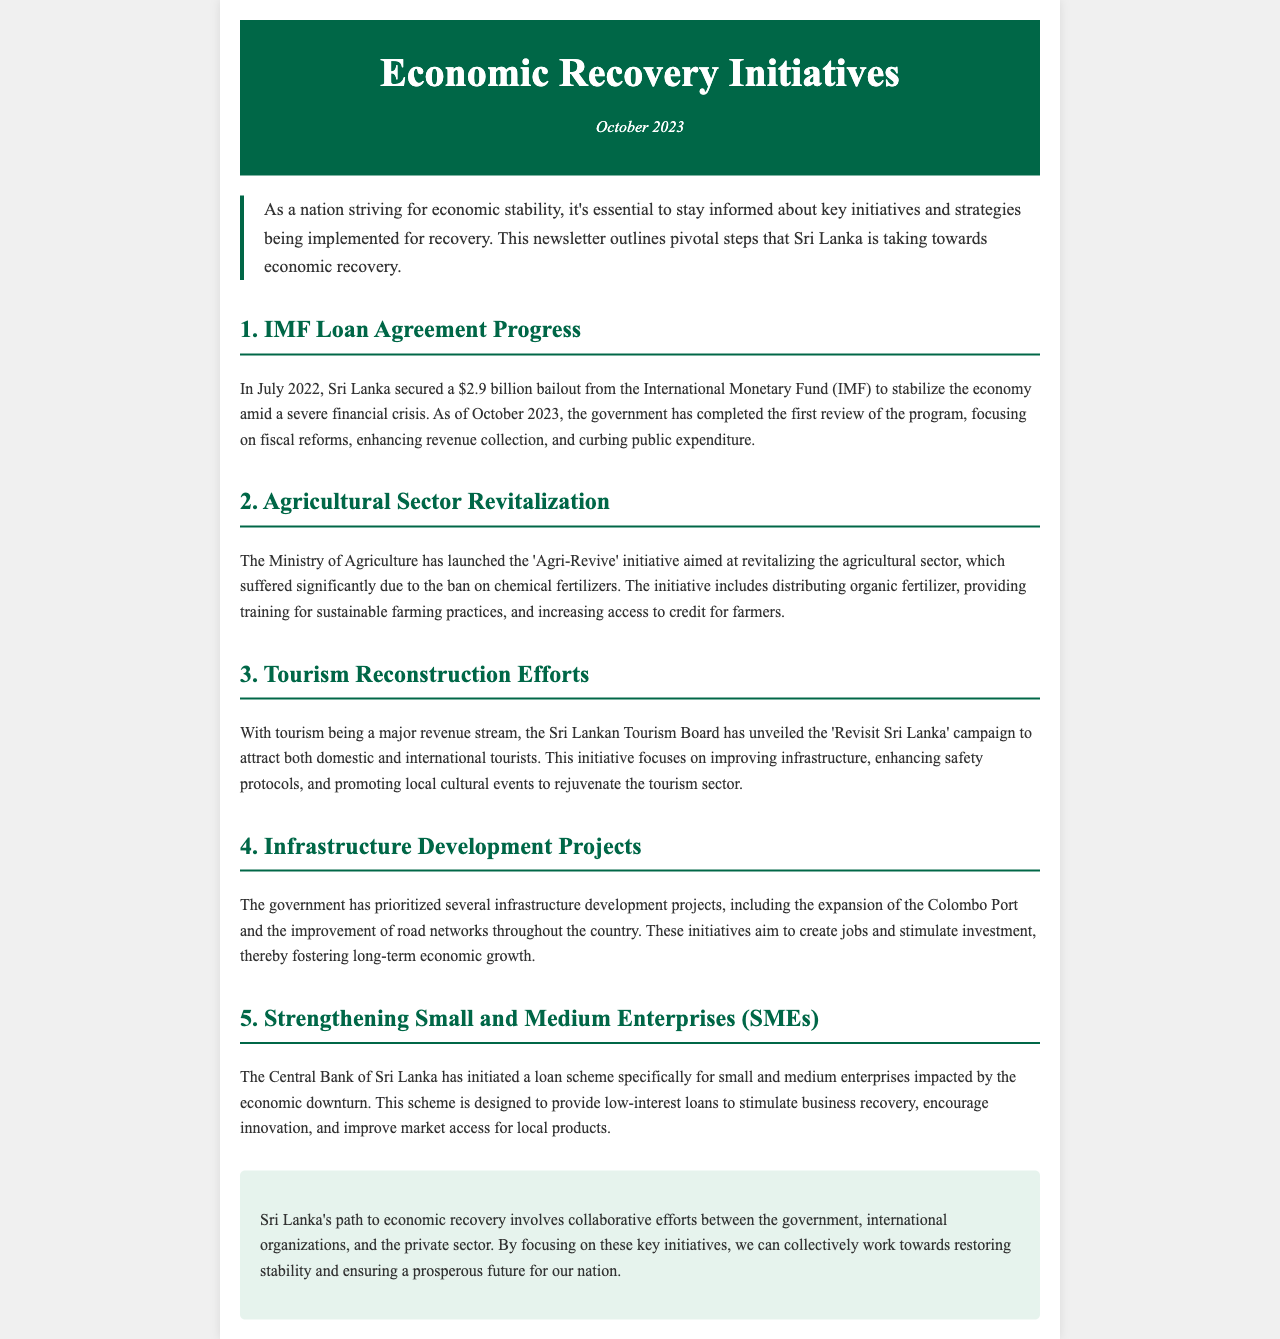What is the total amount of the IMF loan agreement? The IMF loan agreement secured by Sri Lanka is for $2.9 billion.
Answer: $2.9 billion What initiative has the Ministry of Agriculture launched? The initiative launched by the Ministry of Agriculture is called 'Agri-Revive'.
Answer: Agri-Revive What is the aim of the 'Revisit Sri Lanka' campaign? The aim of the campaign is to attract both domestic and international tourists.
Answer: Attract tourists What sector is being prioritized for revitalization due to a past ban? The agricultural sector is being prioritized for revitalization due to the ban on chemical fertilizers.
Answer: Agricultural sector Who has initiated a loan scheme for small and medium enterprises? The loan scheme for SMEs has been initiated by the Central Bank of Sri Lanka.
Answer: Central Bank of Sri Lanka What is one focus of the infrastructure development projects mentioned? One focus of the infrastructure development projects is the expansion of the Colombo Port.
Answer: Expansion of Colombo Port How many reviews of the IMF program had been completed by October 2023? As of October 2023, the government has completed the first review of the IMF program.
Answer: First review 